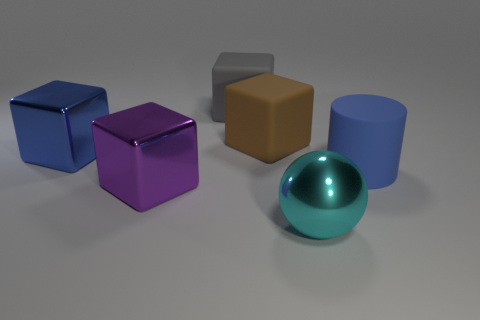There is a metal thing behind the blue cylinder; does it have the same size as the sphere?
Ensure brevity in your answer.  Yes. Are the large cyan sphere and the blue object that is behind the blue rubber object made of the same material?
Provide a short and direct response. Yes. Is the number of large blue rubber cylinders that are in front of the cyan object less than the number of big blocks in front of the blue matte thing?
Keep it short and to the point. Yes. What is the color of the large cylinder that is the same material as the big gray cube?
Your answer should be very brief. Blue. Are there any large cyan objects that are to the left of the thing on the right side of the big cyan sphere?
Make the answer very short. Yes. There is a ball that is the same size as the blue rubber object; what is its color?
Give a very brief answer. Cyan. How many objects are either large cyan rubber balls or cyan metallic balls?
Provide a short and direct response. 1. How many big metal things have the same color as the large cylinder?
Your response must be concise. 1. What number of large gray objects have the same material as the cyan object?
Keep it short and to the point. 0. What number of objects are blue balls or big blue objects that are to the left of the big gray block?
Keep it short and to the point. 1. 